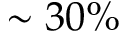<formula> <loc_0><loc_0><loc_500><loc_500>\sim 3 0 \%</formula> 